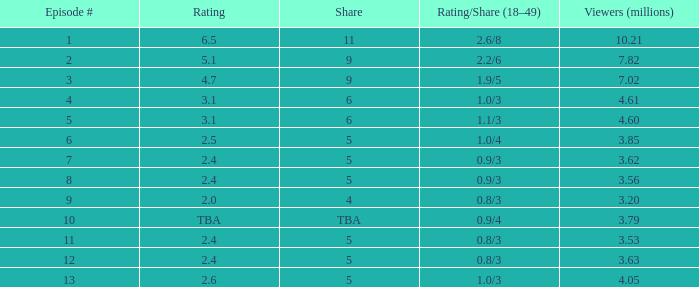What is the smallest numbered episode with a rating/share of None. 